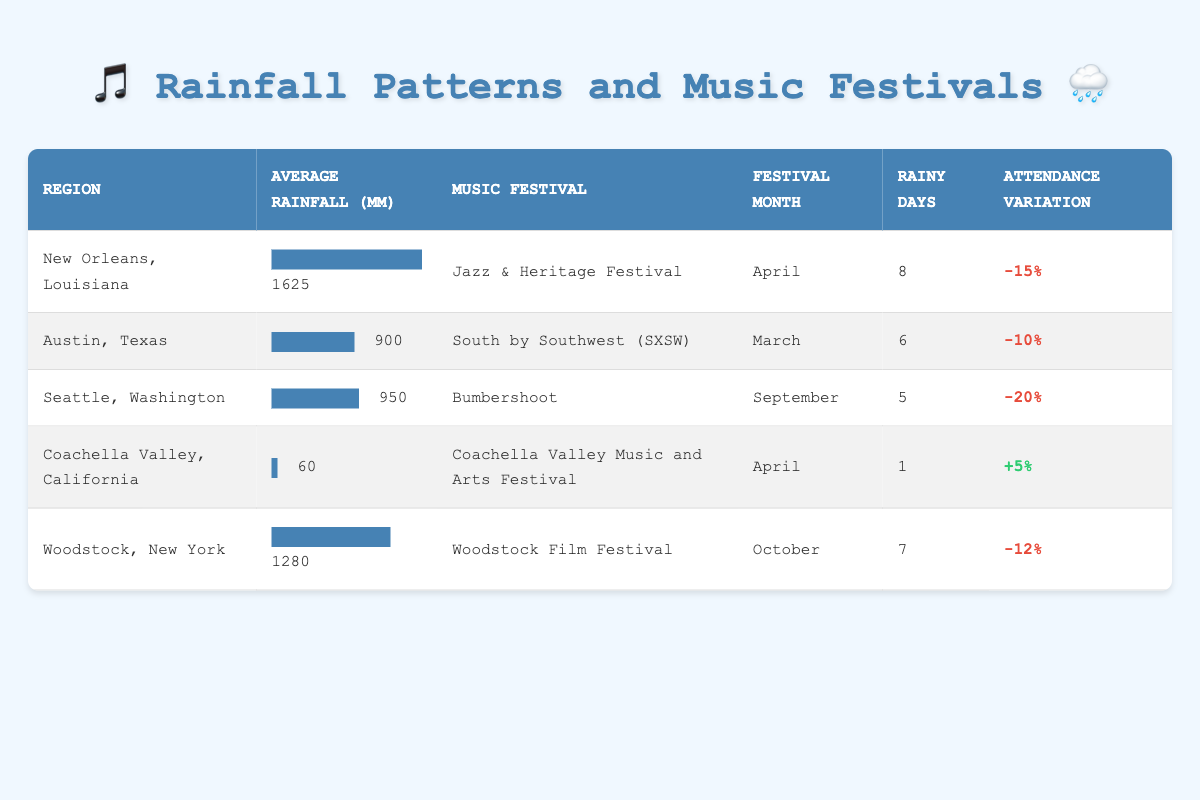What is the average rainfall in New Orleans, Louisiana? The table shows that the average rainfall for New Orleans, Louisiana is 1625 mm.
Answer: 1625 mm Which festival has the highest negative attendance variation and what is the percentage? By examining the attendance variation percentages, Seattle, Washington has the highest negative attendance variation at -20% during the Bumbershoot festival.
Answer: Bumbershoot, -20% How many rainy days are associated with the Coachella Valley Music and Arts Festival? The table indicates that the Coachella Valley Music and Arts Festival has 1 rainy day associated with it.
Answer: 1 If we compare New Orleans and Woodstock, which region has a greater average rainfall and by how much? New Orleans has an average rainfall of 1625 mm while Woodstock has an average rainfall of 1280 mm. The difference is calculated as 1625 - 1280 = 345 mm. Therefore, New Orleans has 345 mm more rainfall than Woodstock.
Answer: 345 mm Is the attendance variation for the South by Southwest (SXSW) festival positive or negative? The table shows that the attendance variation for South by Southwest (SXSW) is -10%, indicating a negative variation.
Answer: Negative 